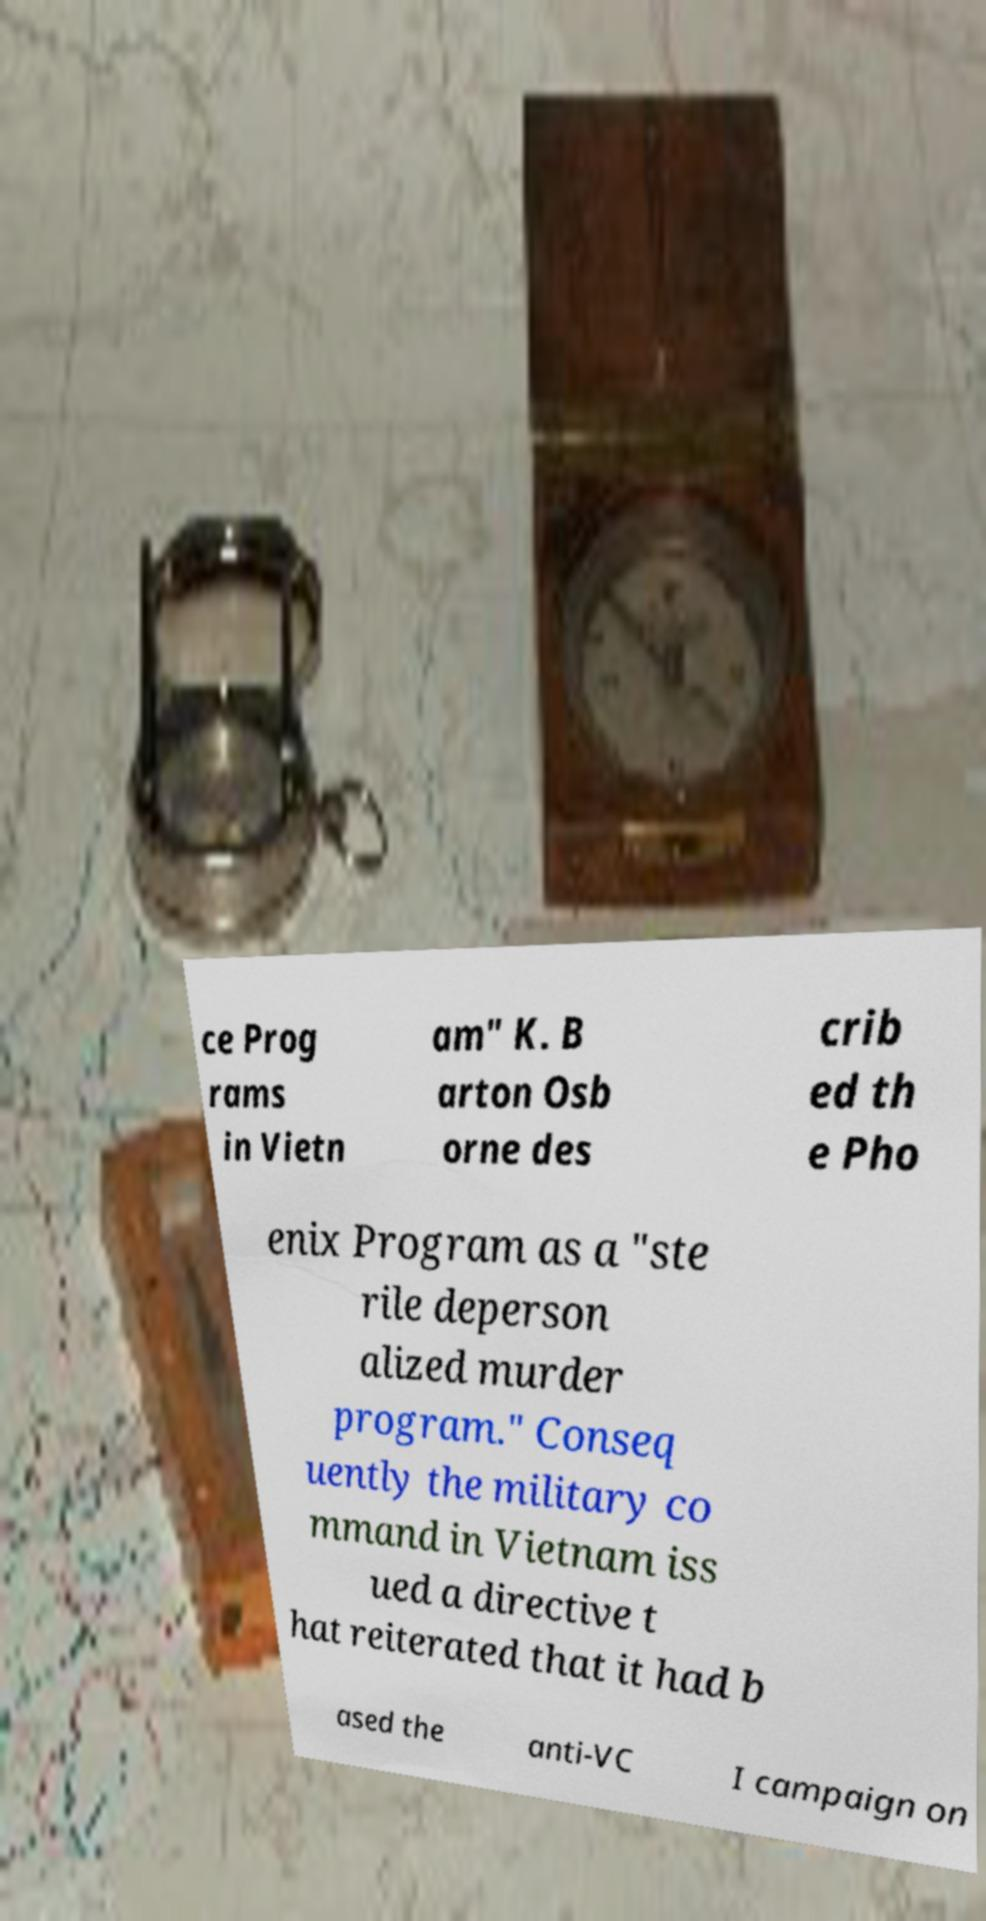Please identify and transcribe the text found in this image. ce Prog rams in Vietn am" K. B arton Osb orne des crib ed th e Pho enix Program as a "ste rile deperson alized murder program." Conseq uently the military co mmand in Vietnam iss ued a directive t hat reiterated that it had b ased the anti-VC I campaign on 